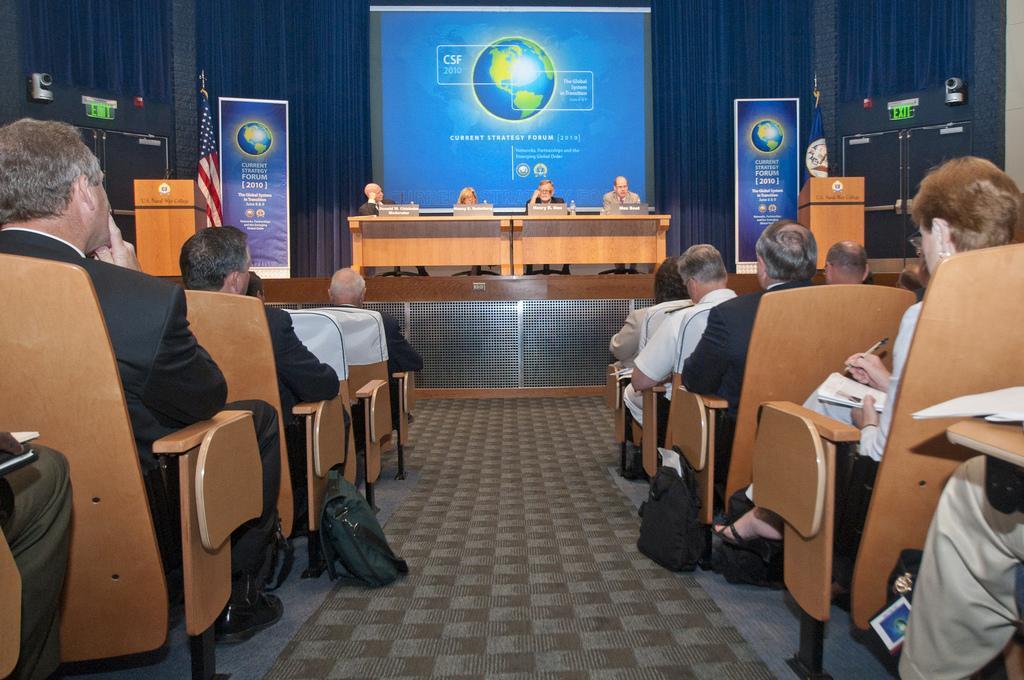Please provide a concise description of this image. At the bottom of the image few people are sitting on chairs and holding some books and pens. In front of them we can see a table, on the table we can see some bottles. Behind the table few people are sitting. Besides the table we can see podiums, flags and banners. Behind them we can see a screen and sign boards. 